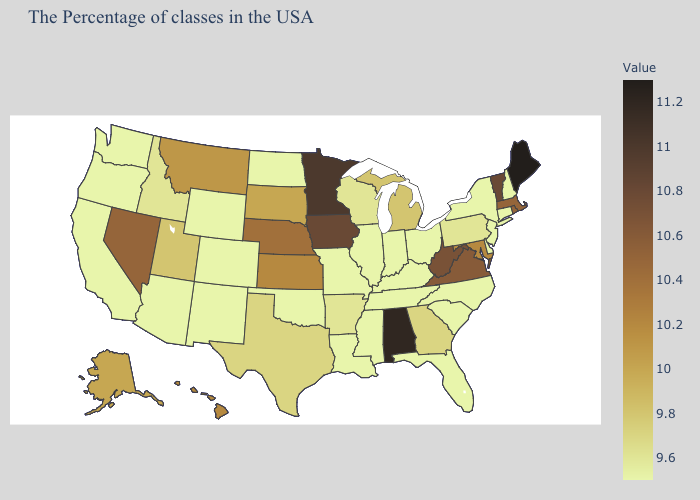Which states have the highest value in the USA?
Answer briefly. Maine. Among the states that border Massachusetts , which have the highest value?
Keep it brief. Vermont. Does Maine have the highest value in the USA?
Short answer required. Yes. Is the legend a continuous bar?
Write a very short answer. Yes. 